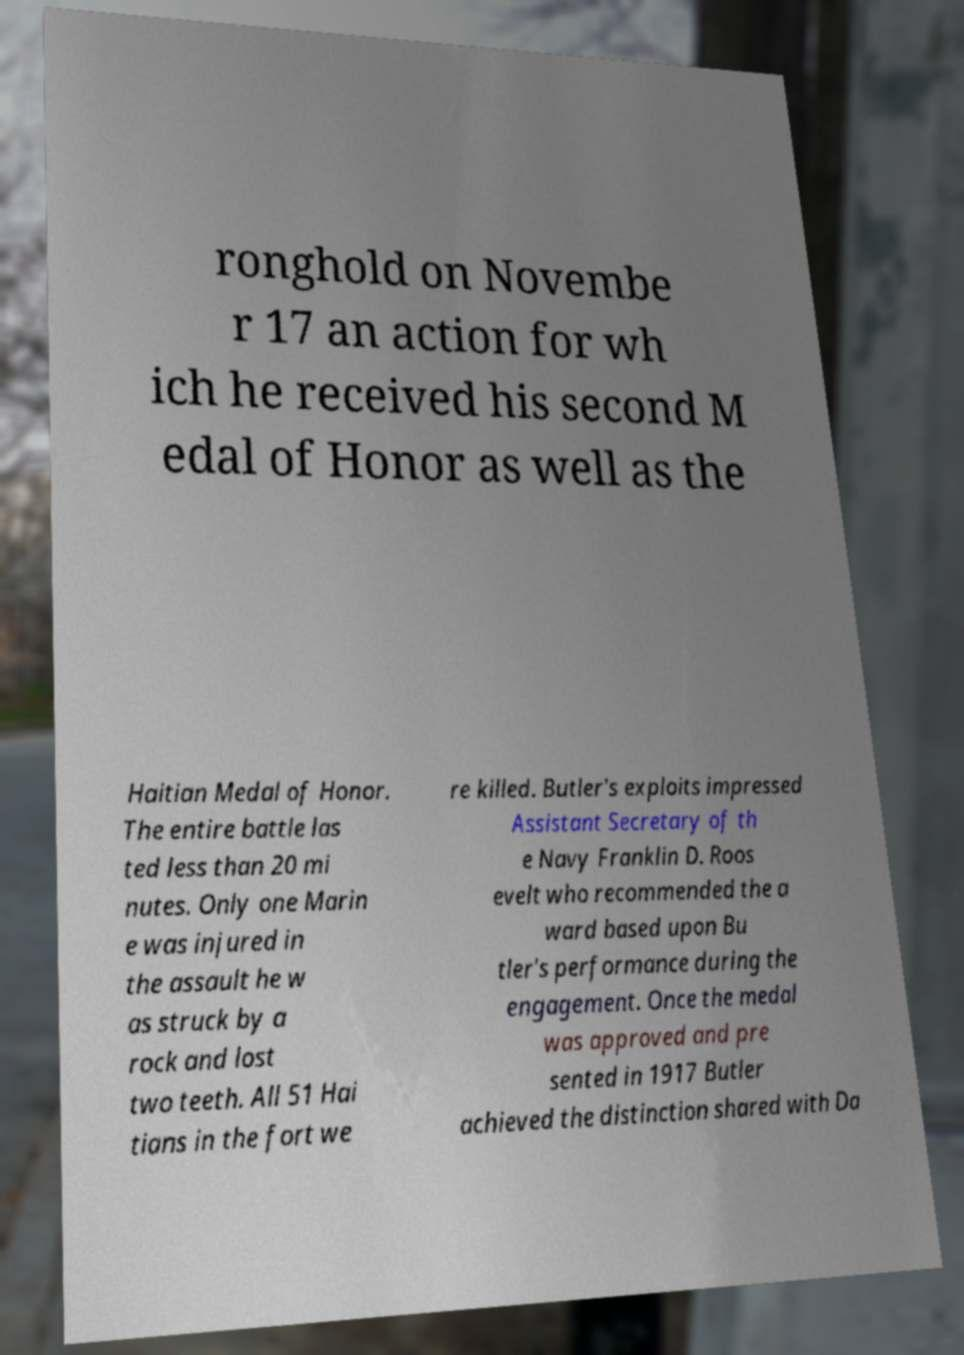There's text embedded in this image that I need extracted. Can you transcribe it verbatim? ronghold on Novembe r 17 an action for wh ich he received his second M edal of Honor as well as the Haitian Medal of Honor. The entire battle las ted less than 20 mi nutes. Only one Marin e was injured in the assault he w as struck by a rock and lost two teeth. All 51 Hai tians in the fort we re killed. Butler's exploits impressed Assistant Secretary of th e Navy Franklin D. Roos evelt who recommended the a ward based upon Bu tler's performance during the engagement. Once the medal was approved and pre sented in 1917 Butler achieved the distinction shared with Da 